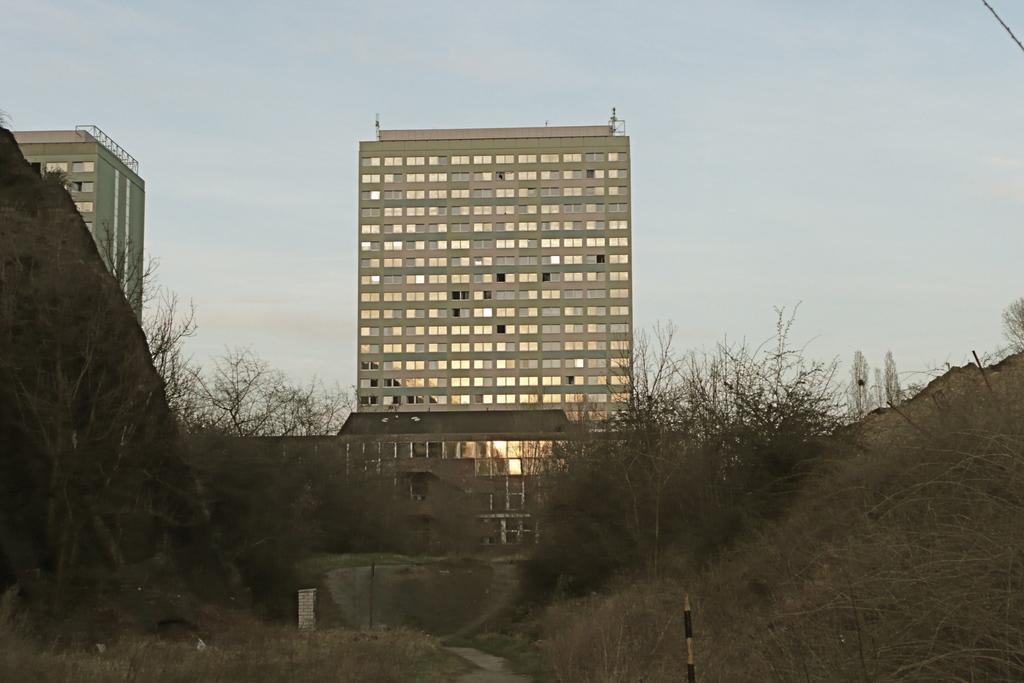Please provide a concise description of this image. In this picture, we can see trees, buildings, sky and other things. 